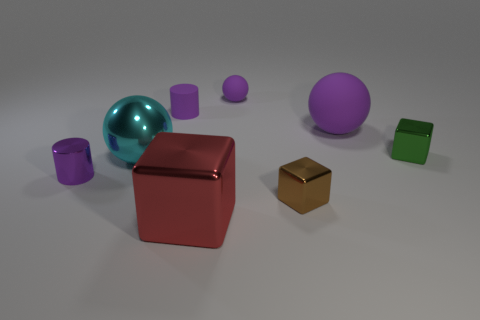Does the large rubber object have the same color as the sphere that is in front of the tiny green shiny object? The large rubber object, which appears to be a semi-translucent teal sphere, does not have the same color as the solid purple sphere positioned in front of the smaller green cube with a shiny surface. 